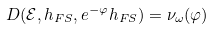Convert formula to latex. <formula><loc_0><loc_0><loc_500><loc_500>D ( \mathcal { E } , h _ { F S } , e ^ { - \varphi } h _ { F S } ) = \nu _ { \omega } ( \varphi )</formula> 